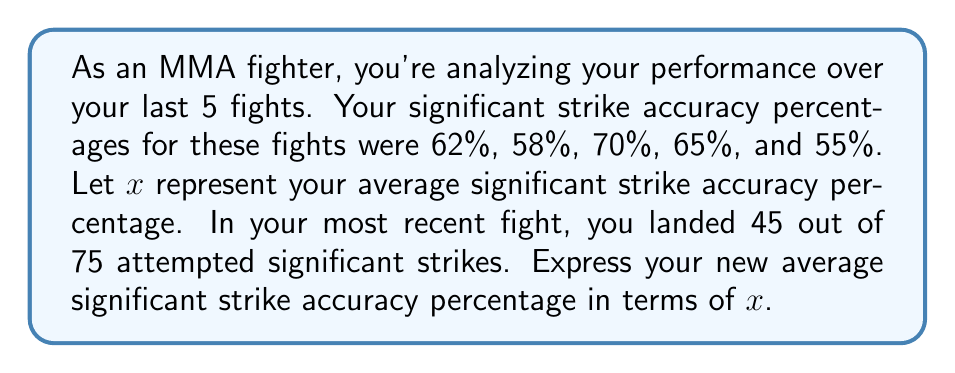What is the answer to this math problem? Let's approach this step-by-step:

1) First, we need to calculate the average of the given 5 fights:
   $x = \frac{62 + 58 + 70 + 65 + 55}{5} = 62\%$

2) Now, we have 6 fights in total (the previous 5 plus the new one).

3) For the new fight, the accuracy is:
   $\frac{45}{75} = 0.6 = 60\%$

4) To calculate the new average, we need to:
   a) Multiply the old average by 5 (to get the total of the old percentages)
   b) Add the new percentage
   c) Divide by 6 (the new total number of fights)

5) Expressing this algebraically:
   $\text{New Average} = \frac{5x + 60}{6}$

6) If we wanted to calculate the actual value, we could substitute $x = 62$:
   $\text{New Average} = \frac{5(62) + 60}{6} = \frac{370}{6} = 61.67\%$

However, the question asks for the expression in terms of $x$, so our final answer is $\frac{5x + 60}{6}$.
Answer: $\frac{5x + 60}{6}$ 